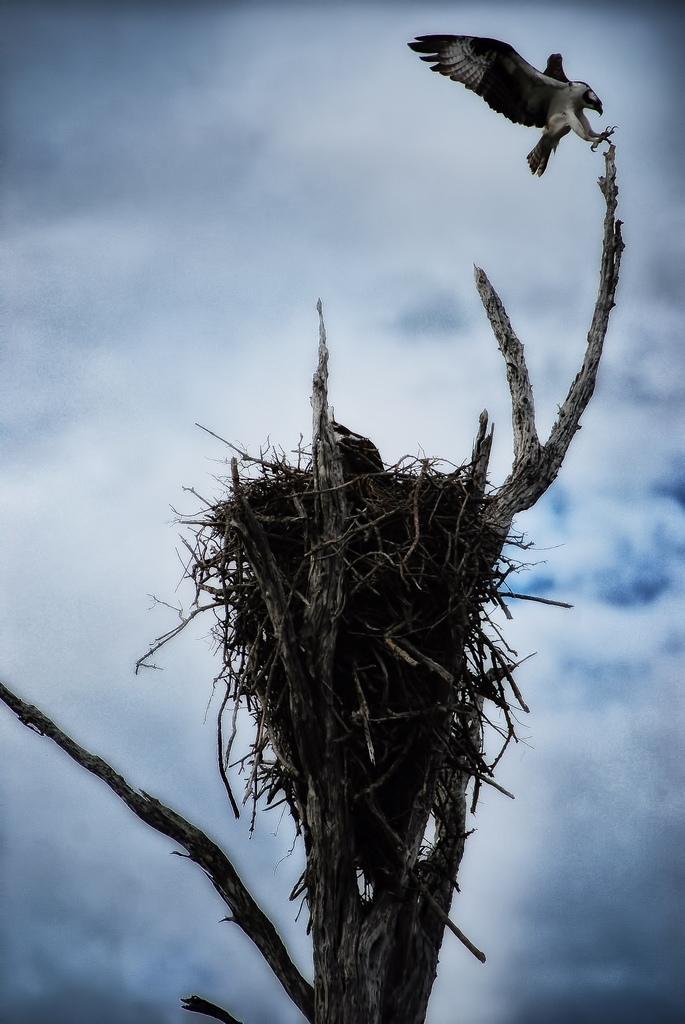How would you summarize this image in a sentence or two? In this image there is a nest on a tree. Here there is a bird. The sky is cloudy. 